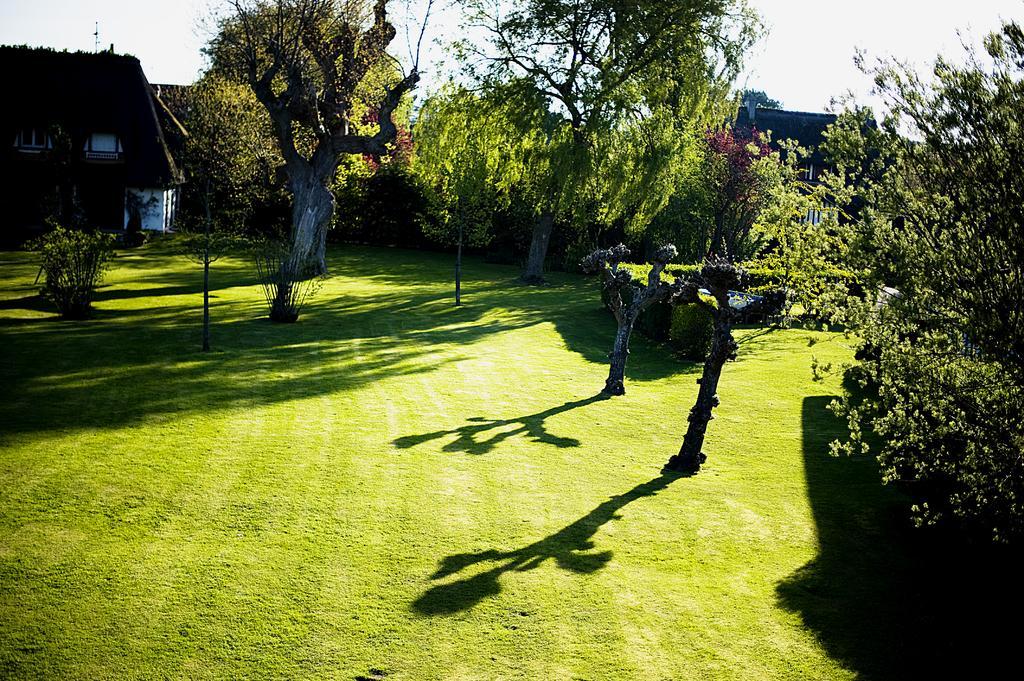Could you give a brief overview of what you see in this image? In this image, I can see the trees with branches and leaves. These are the small bushes. I can see the shadow of the trees on the grass. This looks like a house with windows. 